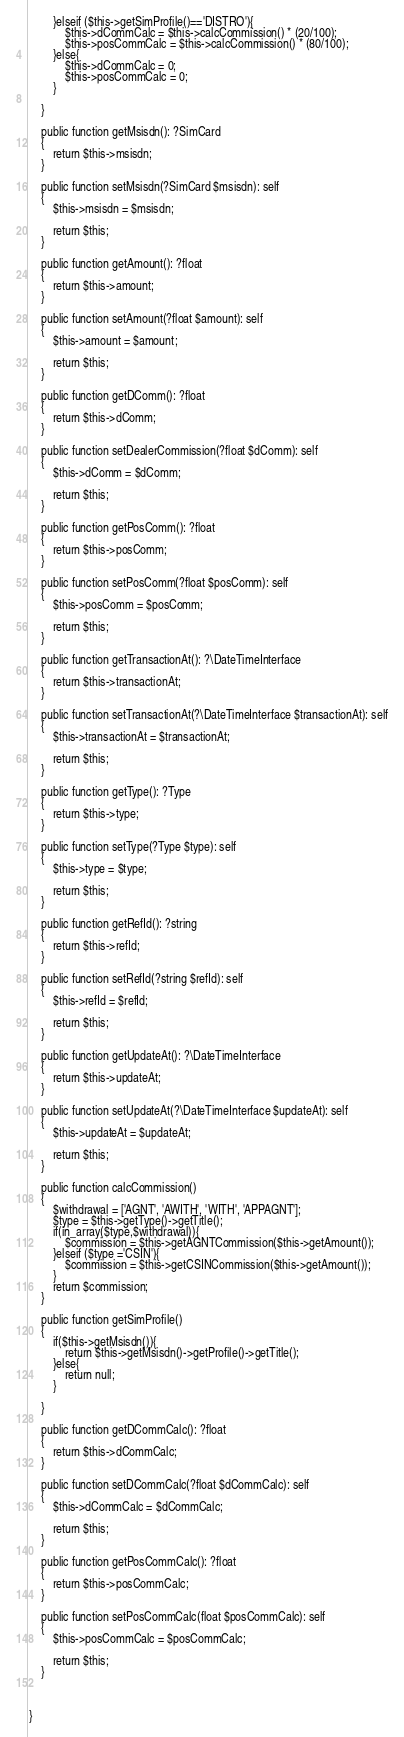<code> <loc_0><loc_0><loc_500><loc_500><_PHP_>        }elseif ($this->getSimProfile()=='DISTRO'){
            $this->dCommCalc = $this->calcCommission() * (20/100);
            $this->posCommCalc = $this->calcCommission() * (80/100);
        }else{
            $this->dCommCalc = 0;
            $this->posCommCalc = 0;
        }

    }

    public function getMsisdn(): ?SimCard
    {
        return $this->msisdn;
    }

    public function setMsisdn(?SimCard $msisdn): self
    {
        $this->msisdn = $msisdn;

        return $this;
    }

    public function getAmount(): ?float
    {
        return $this->amount;
    }

    public function setAmount(?float $amount): self
    {
        $this->amount = $amount;

        return $this;
    }

    public function getDComm(): ?float
    {
        return $this->dComm;
    }

    public function setDealerCommission(?float $dComm): self
    {
        $this->dComm = $dComm;

        return $this;
    }

    public function getPosComm(): ?float
    {
        return $this->posComm;
    }

    public function setPosComm(?float $posComm): self
    {
        $this->posComm = $posComm;

        return $this;
    }

    public function getTransactionAt(): ?\DateTimeInterface
    {
        return $this->transactionAt;
    }

    public function setTransactionAt(?\DateTimeInterface $transactionAt): self
    {
        $this->transactionAt = $transactionAt;

        return $this;
    }

    public function getType(): ?Type
    {
        return $this->type;
    }

    public function setType(?Type $type): self
    {
        $this->type = $type;

        return $this;
    }

    public function getRefId(): ?string
    {
        return $this->refId;
    }

    public function setRefId(?string $refId): self
    {
        $this->refId = $refId;

        return $this;
    }

    public function getUpdateAt(): ?\DateTimeInterface
    {
        return $this->updateAt;
    }

    public function setUpdateAt(?\DateTimeInterface $updateAt): self
    {
        $this->updateAt = $updateAt;

        return $this;
    }

    public function calcCommission()
    {
        $withdrawal = ['AGNT', 'AWITH', 'WITH', 'APPAGNT'];
        $type = $this->getType()->getTitle();
        if(in_array($type,$withdrawal)){
            $commission = $this->getAGNTCommission($this->getAmount());
        }elseif ($type ='CSIN'){
            $commission = $this->getCSINCommission($this->getAmount());
        }
        return $commission;
    }

    public function getSimProfile()
    {
        if($this->getMsisdn()){
            return $this->getMsisdn()->getProfile()->getTitle();
        }else{
            return null;
        }

    }

    public function getDCommCalc(): ?float
    {
        return $this->dCommCalc;
    }

    public function setDCommCalc(?float $dCommCalc): self
    {
        $this->dCommCalc = $dCommCalc;

        return $this;
    }

    public function getPosCommCalc(): ?float
    {
        return $this->posCommCalc;
    }

    public function setPosCommCalc(float $posCommCalc): self
    {
        $this->posCommCalc = $posCommCalc;

        return $this;
    }



}
</code> 